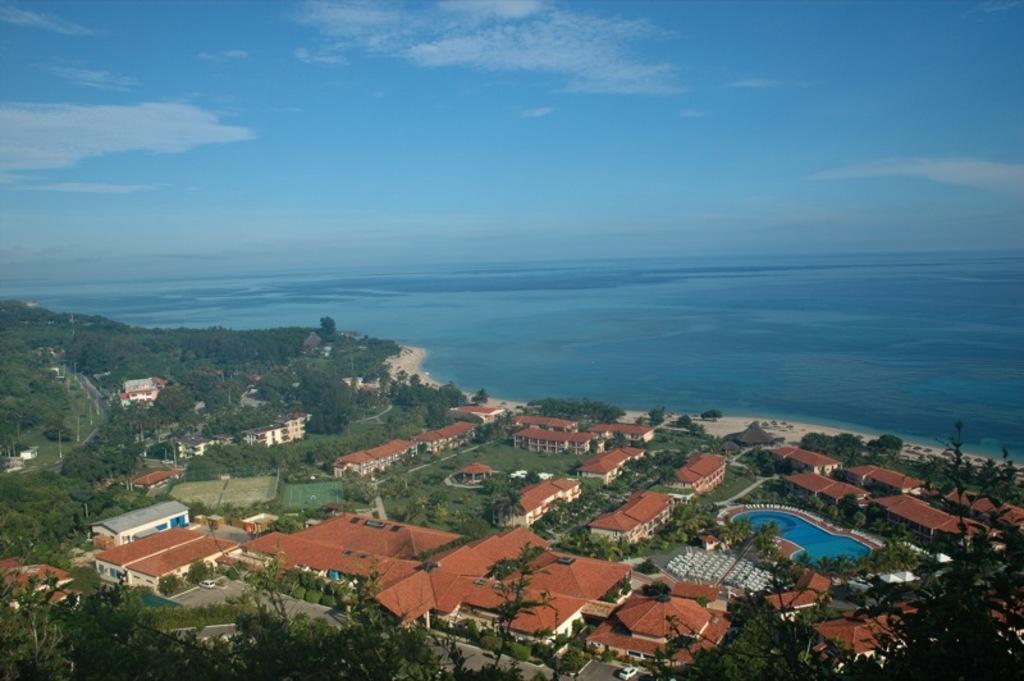Please provide a concise description of this image. In this picture we can see few houses, trees and poles, in the background we can see water and clouds. 